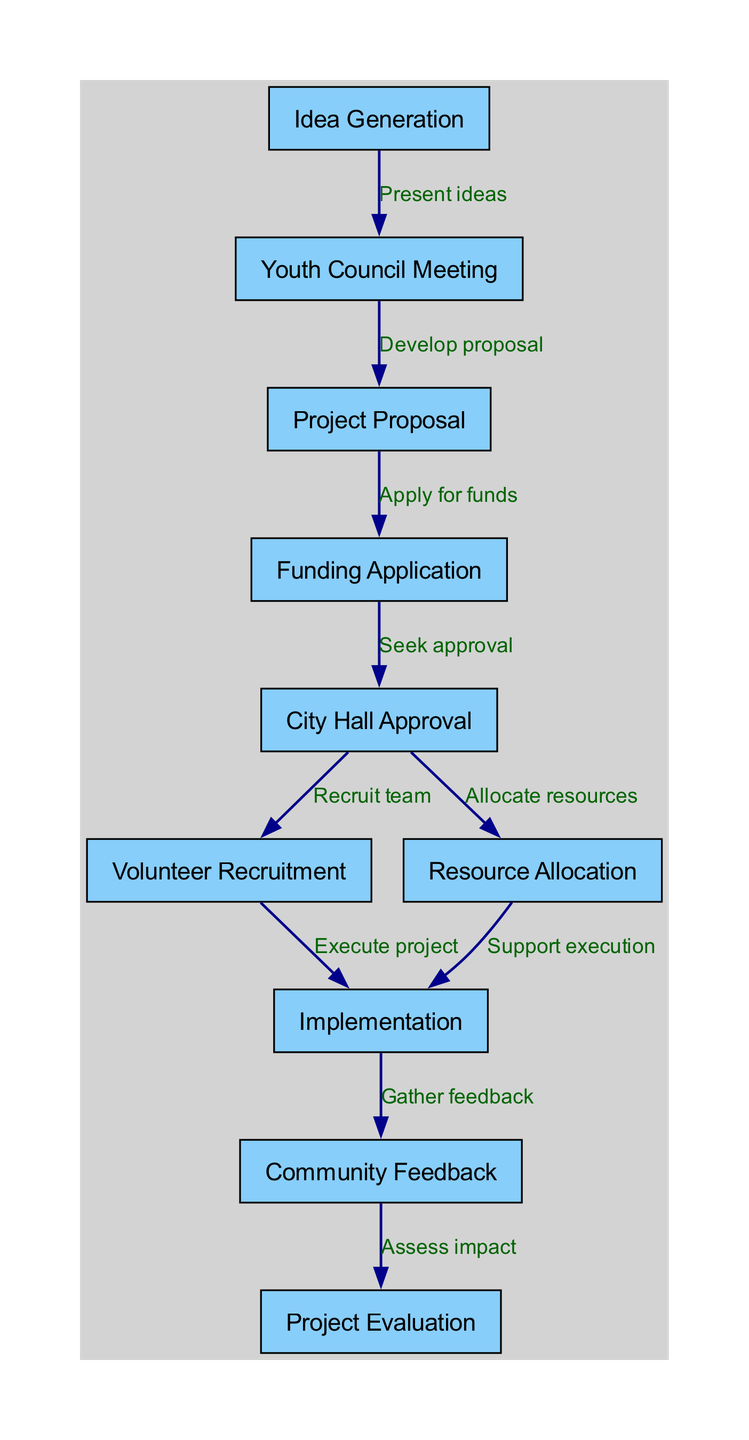What is the first step in the project lifecycle? The diagram shows "Idea Generation" as the initial node from which the project lifecycle begins.
Answer: Idea Generation How many nodes are present in the diagram? By counting the individual nodes listed in the diagram, we find a total of ten distinct nodes representing steps in the project lifecycle.
Answer: 10 What follows after "Youth Council Meeting"? The diagram indicates that "Project Proposal" follows "Youth Council Meeting" as the next step in the project lifecycle.
Answer: Project Proposal What is the last step in the project lifecycle? The final node in the directed graph is "Project Evaluation," representing the concluding phase of the project lifecycle.
Answer: Project Evaluation Which node is linked to both "Volunteer Recruitment" and "Resource Allocation"? The diagram illustrates that "City Hall Approval" has directed edges leading to both "Volunteer Recruitment" and "Resource Allocation."
Answer: City Hall Approval How many edges are there in total in the diagram? Each connection between the nodes counts as an edge, and by reviewing the connections, we determine that there are nine edges present.
Answer: 9 What is the label for the edge from "Implementation" to "Community Feedback"? The edge from "Implementation" to "Community Feedback" is labeled "Gather feedback," indicating the action taken during this transition.
Answer: Gather feedback Which two nodes are connected by the edge labeled "Assess impact"? According to the diagram, "Community Feedback" and "Project Evaluation" are connected by the edge labeled "Assess impact."
Answer: Community Feedback and Project Evaluation What is the relationship between "Funding Application" and "City Hall Approval"? The diagram shows that "City Hall Approval" depends on the "Funding Application," as it is a subsequent step following it.
Answer: Seek approval 